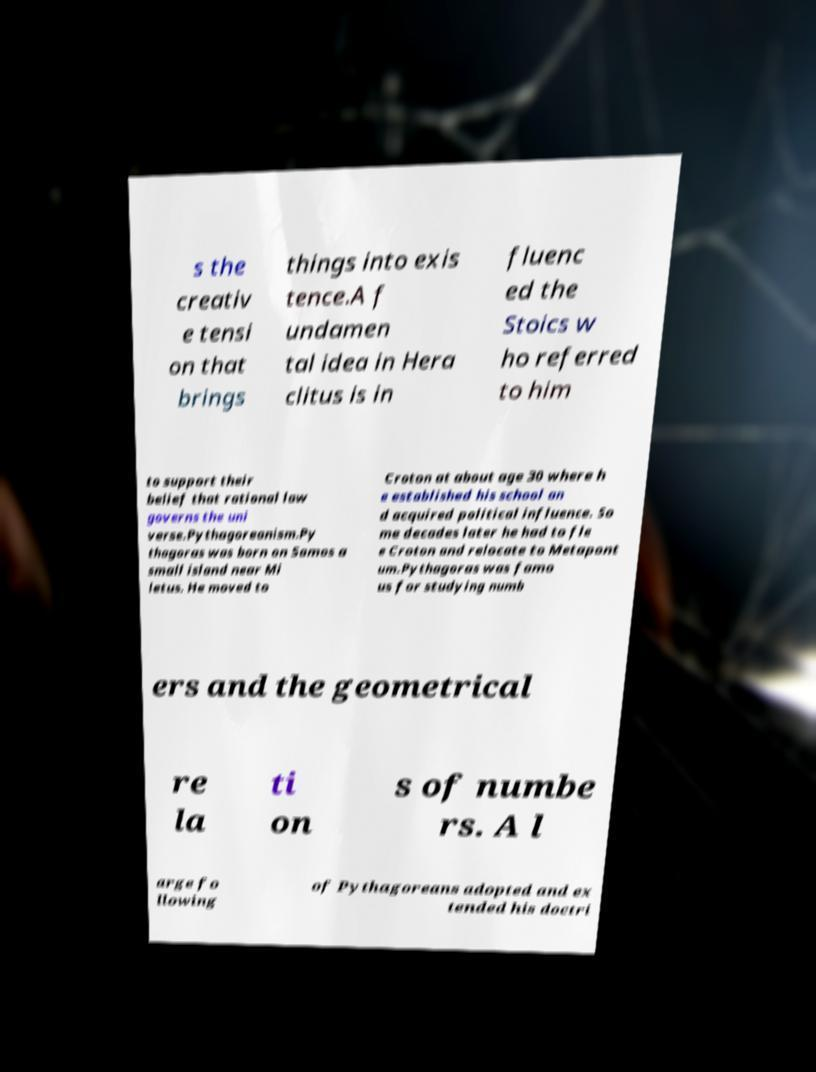For documentation purposes, I need the text within this image transcribed. Could you provide that? s the creativ e tensi on that brings things into exis tence.A f undamen tal idea in Hera clitus is in fluenc ed the Stoics w ho referred to him to support their belief that rational law governs the uni verse.Pythagoreanism.Py thagoras was born on Samos a small island near Mi letus. He moved to Croton at about age 30 where h e established his school an d acquired political influence. So me decades later he had to fle e Croton and relocate to Metapont um.Pythagoras was famo us for studying numb ers and the geometrical re la ti on s of numbe rs. A l arge fo llowing of Pythagoreans adopted and ex tended his doctri 